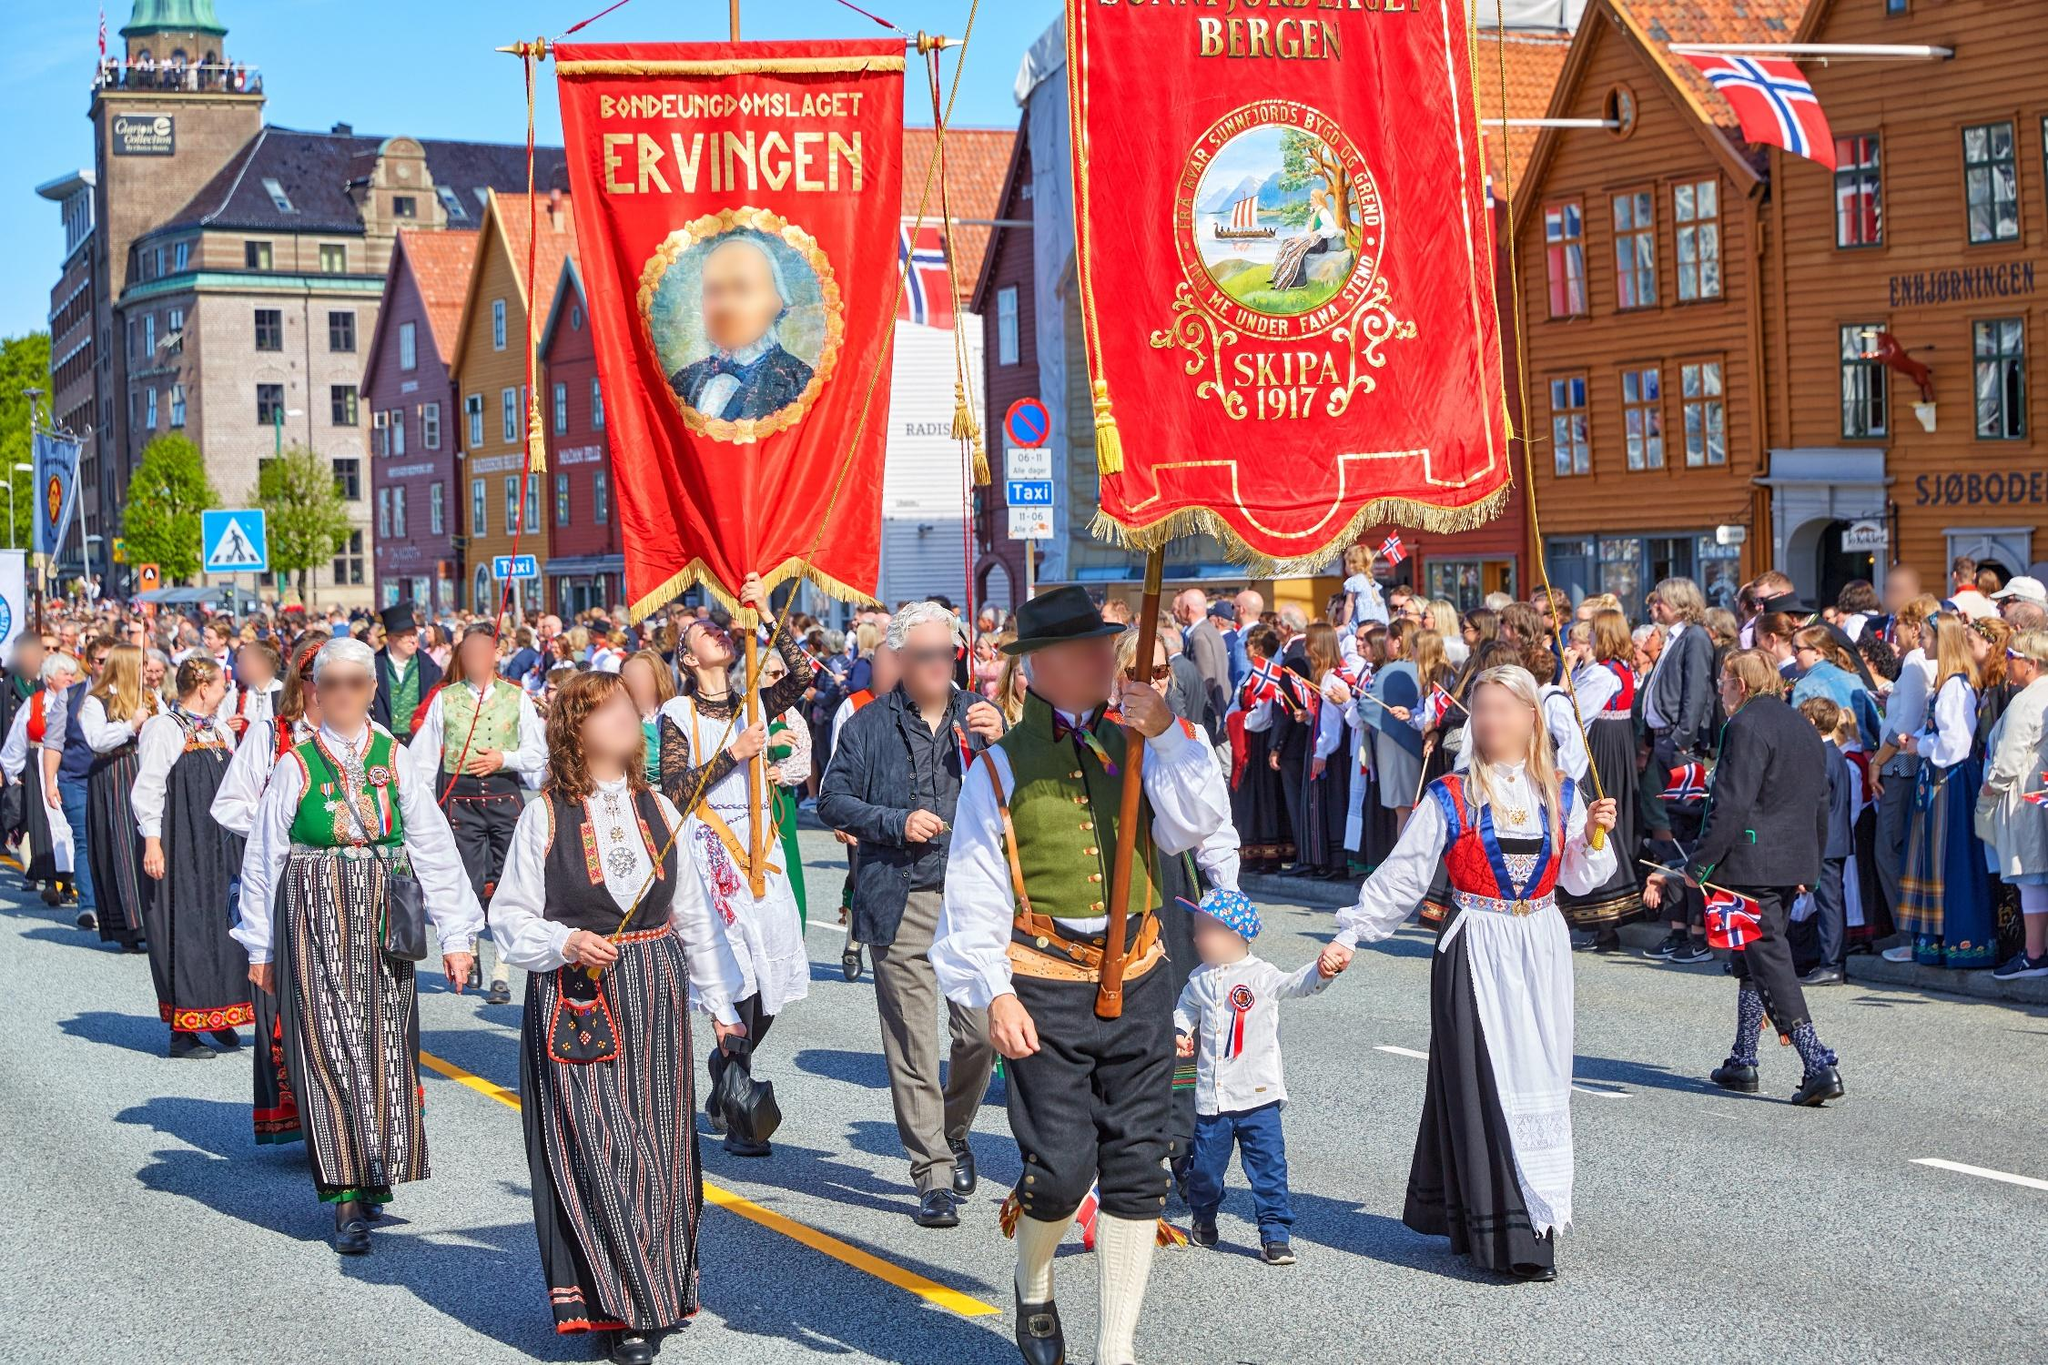Describe a realistic scenario where this image was taken during a significant cultural celebration in Norway. This image could realistically depict a parade during the Norwegian Constitution Day, celebrated on May 17th, known as Syttende Mai. It is a day of immense national pride, marked by parades, traditional music, and public speeches. People of all ages don their finest bunads, representing different regions of Norway. Large and small communities alike gather to take part in the festivities, which include children’s parades and the waving of the red, white, and blue Norwegian flag. This celebration reflects Norway’s values of democracy, unity, and cultural heritage, making it one of the most significant national holidays. 